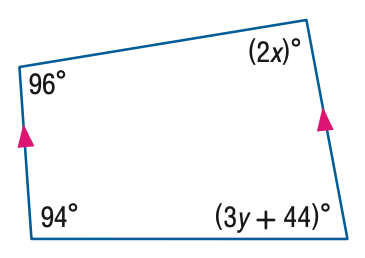Answer the mathemtical geometry problem and directly provide the correct option letter.
Question: Find the value of the variable x in the figure.
Choices: A: 42 B: 47 C: 48 D: 96 A 